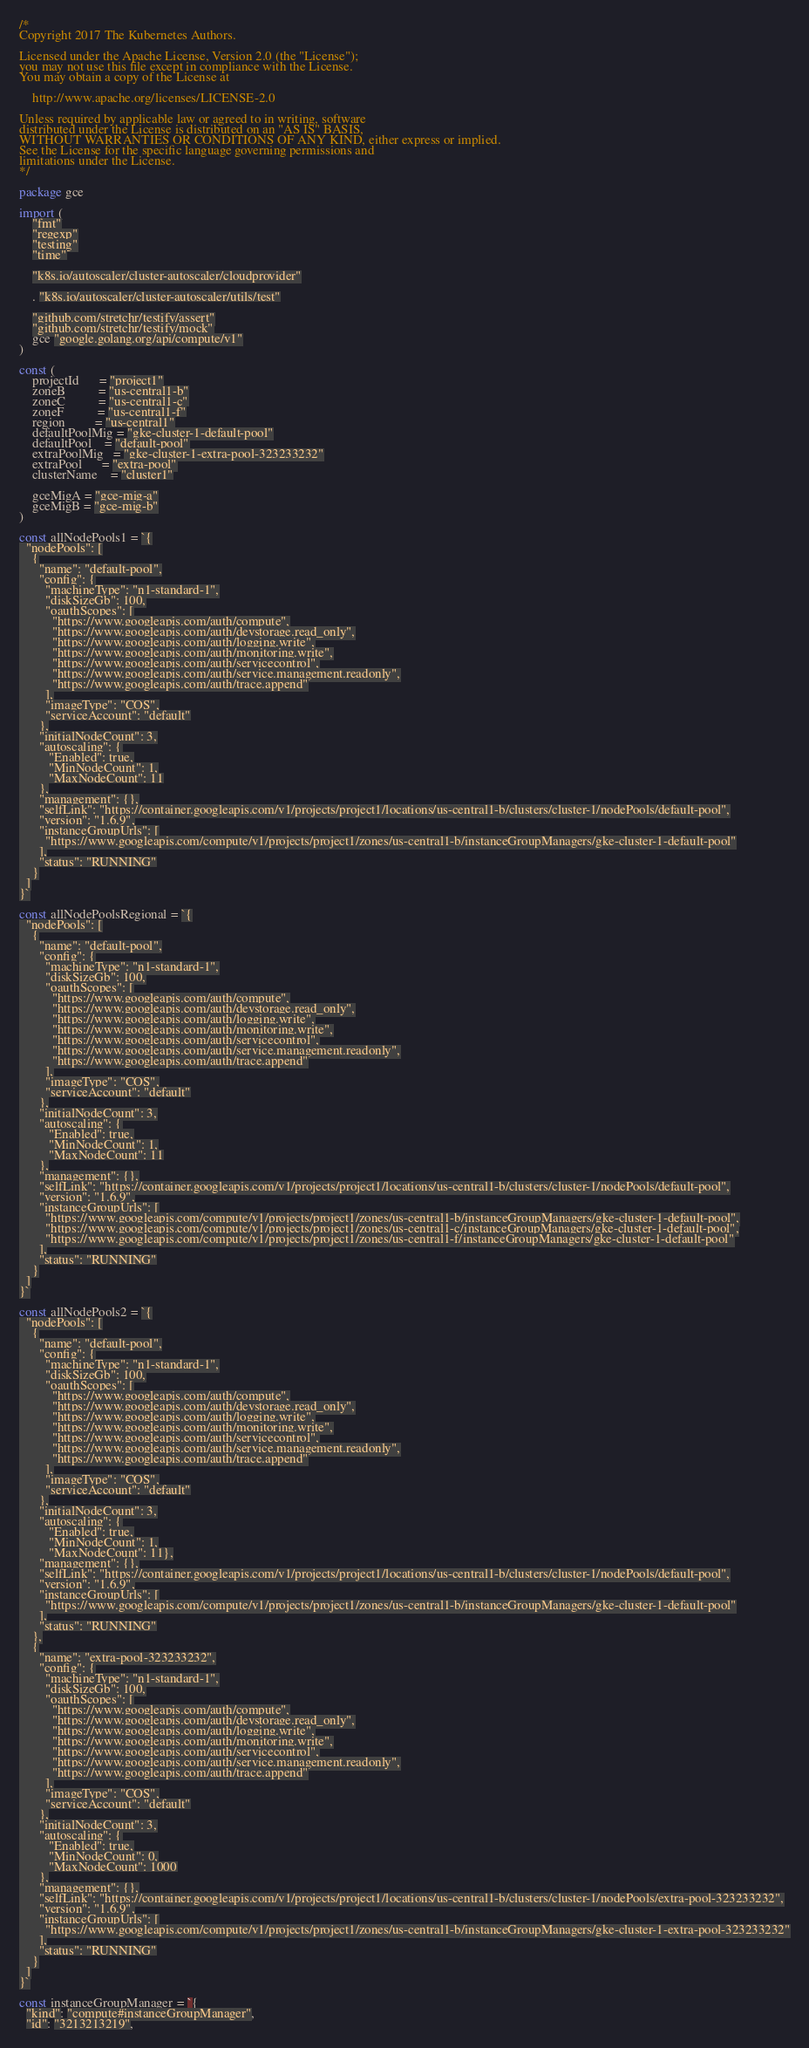Convert code to text. <code><loc_0><loc_0><loc_500><loc_500><_Go_>/*
Copyright 2017 The Kubernetes Authors.

Licensed under the Apache License, Version 2.0 (the "License");
you may not use this file except in compliance with the License.
You may obtain a copy of the License at

    http://www.apache.org/licenses/LICENSE-2.0

Unless required by applicable law or agreed to in writing, software
distributed under the License is distributed on an "AS IS" BASIS,
WITHOUT WARRANTIES OR CONDITIONS OF ANY KIND, either express or implied.
See the License for the specific language governing permissions and
limitations under the License.
*/

package gce

import (
	"fmt"
	"regexp"
	"testing"
	"time"

	"k8s.io/autoscaler/cluster-autoscaler/cloudprovider"

	. "k8s.io/autoscaler/cluster-autoscaler/utils/test"

	"github.com/stretchr/testify/assert"
	"github.com/stretchr/testify/mock"
	gce "google.golang.org/api/compute/v1"
)

const (
	projectId      = "project1"
	zoneB          = "us-central1-b"
	zoneC          = "us-central1-c"
	zoneF          = "us-central1-f"
	region         = "us-central1"
	defaultPoolMig = "gke-cluster-1-default-pool"
	defaultPool    = "default-pool"
	extraPoolMig   = "gke-cluster-1-extra-pool-323233232"
	extraPool      = "extra-pool"
	clusterName    = "cluster1"

	gceMigA = "gce-mig-a"
	gceMigB = "gce-mig-b"
)

const allNodePools1 = `{
  "nodePools": [
    {
      "name": "default-pool",
      "config": {
        "machineType": "n1-standard-1",
        "diskSizeGb": 100,
        "oauthScopes": [
          "https://www.googleapis.com/auth/compute",
          "https://www.googleapis.com/auth/devstorage.read_only",
          "https://www.googleapis.com/auth/logging.write",
          "https://www.googleapis.com/auth/monitoring.write",
          "https://www.googleapis.com/auth/servicecontrol",
          "https://www.googleapis.com/auth/service.management.readonly",
          "https://www.googleapis.com/auth/trace.append"
        ],
        "imageType": "COS",
        "serviceAccount": "default"
      },
      "initialNodeCount": 3,
      "autoscaling": {
         "Enabled": true,
         "MinNodeCount": 1,
         "MaxNodeCount": 11
      },
      "management": {},
      "selfLink": "https://container.googleapis.com/v1/projects/project1/locations/us-central1-b/clusters/cluster-1/nodePools/default-pool",
      "version": "1.6.9",
      "instanceGroupUrls": [
        "https://www.googleapis.com/compute/v1/projects/project1/zones/us-central1-b/instanceGroupManagers/gke-cluster-1-default-pool"
      ],
      "status": "RUNNING"
    }
  ]
}`

const allNodePoolsRegional = `{
  "nodePools": [
    {
      "name": "default-pool",
      "config": {
        "machineType": "n1-standard-1",
        "diskSizeGb": 100,
        "oauthScopes": [
          "https://www.googleapis.com/auth/compute",
          "https://www.googleapis.com/auth/devstorage.read_only",
          "https://www.googleapis.com/auth/logging.write",
          "https://www.googleapis.com/auth/monitoring.write",
          "https://www.googleapis.com/auth/servicecontrol",
          "https://www.googleapis.com/auth/service.management.readonly",
          "https://www.googleapis.com/auth/trace.append"
        ],
        "imageType": "COS",
        "serviceAccount": "default"
      },
      "initialNodeCount": 3,
      "autoscaling": {
         "Enabled": true,
         "MinNodeCount": 1,
         "MaxNodeCount": 11
      },
      "management": {},
      "selfLink": "https://container.googleapis.com/v1/projects/project1/locations/us-central1-b/clusters/cluster-1/nodePools/default-pool",
      "version": "1.6.9",
      "instanceGroupUrls": [
        "https://www.googleapis.com/compute/v1/projects/project1/zones/us-central1-b/instanceGroupManagers/gke-cluster-1-default-pool",
        "https://www.googleapis.com/compute/v1/projects/project1/zones/us-central1-c/instanceGroupManagers/gke-cluster-1-default-pool",
        "https://www.googleapis.com/compute/v1/projects/project1/zones/us-central1-f/instanceGroupManagers/gke-cluster-1-default-pool"
      ],
      "status": "RUNNING"
    }
  ]
}`

const allNodePools2 = `{
  "nodePools": [
    {
      "name": "default-pool",
      "config": {
        "machineType": "n1-standard-1",
        "diskSizeGb": 100,
        "oauthScopes": [
          "https://www.googleapis.com/auth/compute",
          "https://www.googleapis.com/auth/devstorage.read_only",
          "https://www.googleapis.com/auth/logging.write",
          "https://www.googleapis.com/auth/monitoring.write",
          "https://www.googleapis.com/auth/servicecontrol",
          "https://www.googleapis.com/auth/service.management.readonly",
          "https://www.googleapis.com/auth/trace.append"
        ],
        "imageType": "COS",
        "serviceAccount": "default"
      },
      "initialNodeCount": 3,
      "autoscaling": {
         "Enabled": true,
         "MinNodeCount": 1,
         "MaxNodeCount": 11},
      "management": {},
      "selfLink": "https://container.googleapis.com/v1/projects/project1/locations/us-central1-b/clusters/cluster-1/nodePools/default-pool",
      "version": "1.6.9",
      "instanceGroupUrls": [
        "https://www.googleapis.com/compute/v1/projects/project1/zones/us-central1-b/instanceGroupManagers/gke-cluster-1-default-pool"
      ],
      "status": "RUNNING"
    },
    {
      "name": "extra-pool-323233232",
      "config": {
        "machineType": "n1-standard-1",
        "diskSizeGb": 100,
        "oauthScopes": [
          "https://www.googleapis.com/auth/compute",
          "https://www.googleapis.com/auth/devstorage.read_only",
          "https://www.googleapis.com/auth/logging.write",
          "https://www.googleapis.com/auth/monitoring.write",
          "https://www.googleapis.com/auth/servicecontrol",
          "https://www.googleapis.com/auth/service.management.readonly",
          "https://www.googleapis.com/auth/trace.append"
        ],
        "imageType": "COS",
        "serviceAccount": "default"
      },
      "initialNodeCount": 3,
      "autoscaling": {
         "Enabled": true,
         "MinNodeCount": 0,
         "MaxNodeCount": 1000
      },
      "management": {},
      "selfLink": "https://container.googleapis.com/v1/projects/project1/locations/us-central1-b/clusters/cluster-1/nodePools/extra-pool-323233232",
      "version": "1.6.9",
      "instanceGroupUrls": [
        "https://www.googleapis.com/compute/v1/projects/project1/zones/us-central1-b/instanceGroupManagers/gke-cluster-1-extra-pool-323233232"
      ],
      "status": "RUNNING"
    }
  ]
}`

const instanceGroupManager = `{
  "kind": "compute#instanceGroupManager",
  "id": "3213213219",</code> 